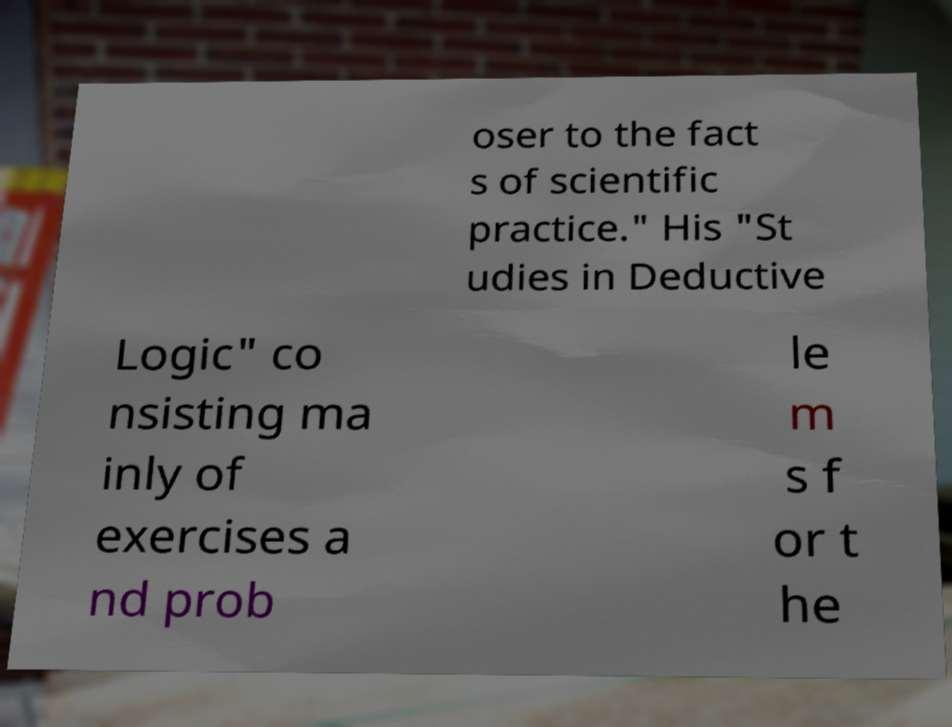Please identify and transcribe the text found in this image. oser to the fact s of scientific practice." His "St udies in Deductive Logic" co nsisting ma inly of exercises a nd prob le m s f or t he 